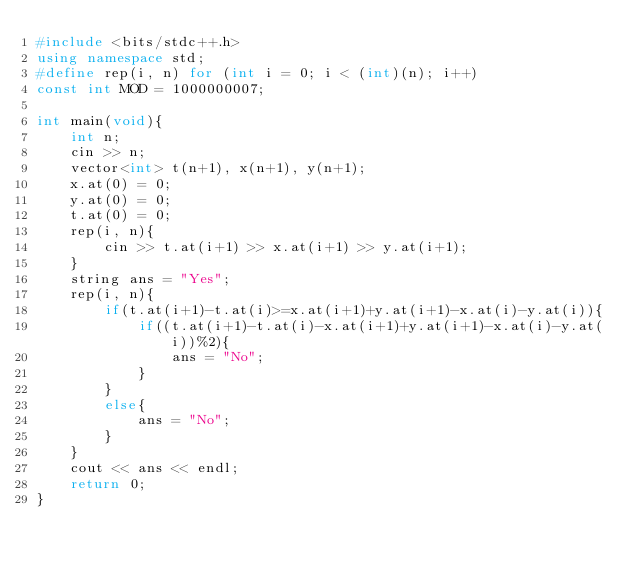Convert code to text. <code><loc_0><loc_0><loc_500><loc_500><_C++_>#include <bits/stdc++.h>
using namespace std;
#define rep(i, n) for (int i = 0; i < (int)(n); i++)
const int MOD = 1000000007;

int main(void){
    int n;
    cin >> n;
    vector<int> t(n+1), x(n+1), y(n+1);
    x.at(0) = 0;
    y.at(0) = 0;
    t.at(0) = 0;
    rep(i, n){
        cin >> t.at(i+1) >> x.at(i+1) >> y.at(i+1);
    }
    string ans = "Yes";
    rep(i, n){
        if(t.at(i+1)-t.at(i)>=x.at(i+1)+y.at(i+1)-x.at(i)-y.at(i)){
            if((t.at(i+1)-t.at(i)-x.at(i+1)+y.at(i+1)-x.at(i)-y.at(i))%2){
                ans = "No";
            }
        }
        else{
            ans = "No";
        }
    }
    cout << ans << endl;
    return 0;
}</code> 